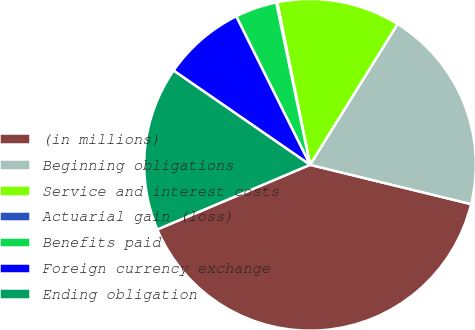Convert chart to OTSL. <chart><loc_0><loc_0><loc_500><loc_500><pie_chart><fcel>(in millions)<fcel>Beginning obligations<fcel>Service and interest costs<fcel>Actuarial gain (loss)<fcel>Benefits paid<fcel>Foreign currency exchange<fcel>Ending obligation<nl><fcel>39.82%<fcel>19.96%<fcel>12.02%<fcel>0.1%<fcel>4.07%<fcel>8.04%<fcel>15.99%<nl></chart> 